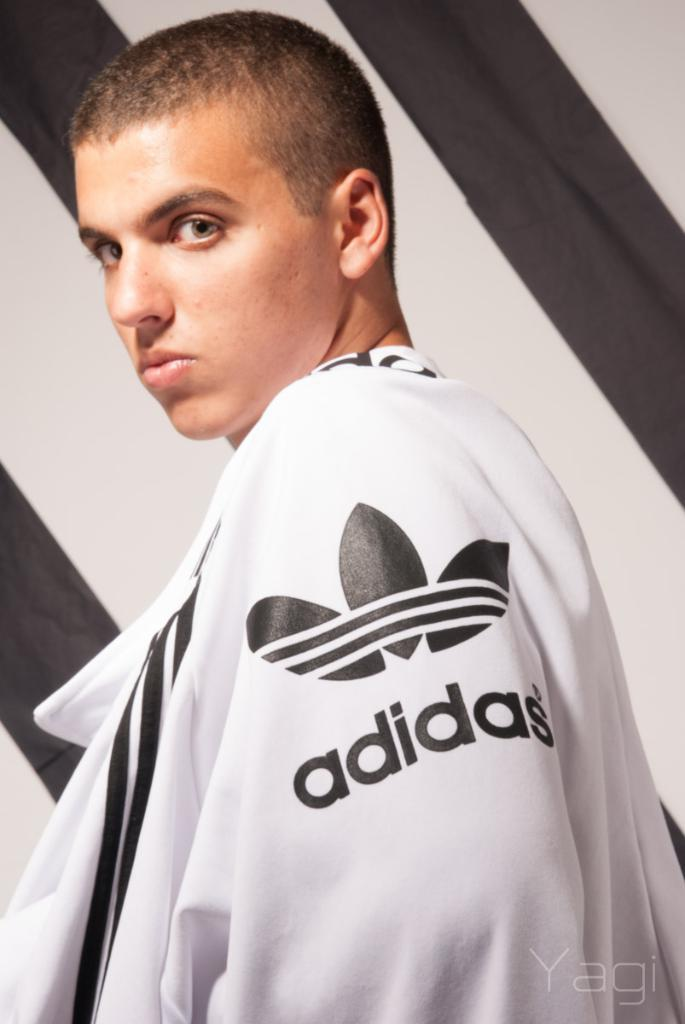<image>
Summarize the visual content of the image. A person wearing a white Adidas jacket stands in front of a black and white wall. 